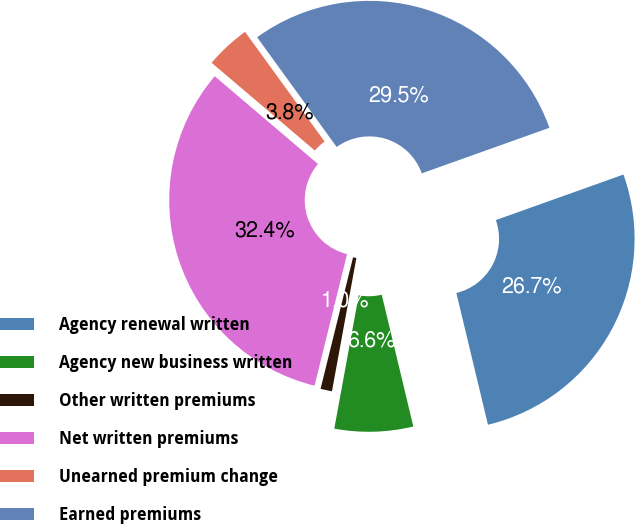<chart> <loc_0><loc_0><loc_500><loc_500><pie_chart><fcel>Agency renewal written<fcel>Agency new business written<fcel>Other written premiums<fcel>Net written premiums<fcel>Unearned premium change<fcel>Earned premiums<nl><fcel>26.71%<fcel>6.63%<fcel>0.97%<fcel>32.36%<fcel>3.8%<fcel>29.53%<nl></chart> 